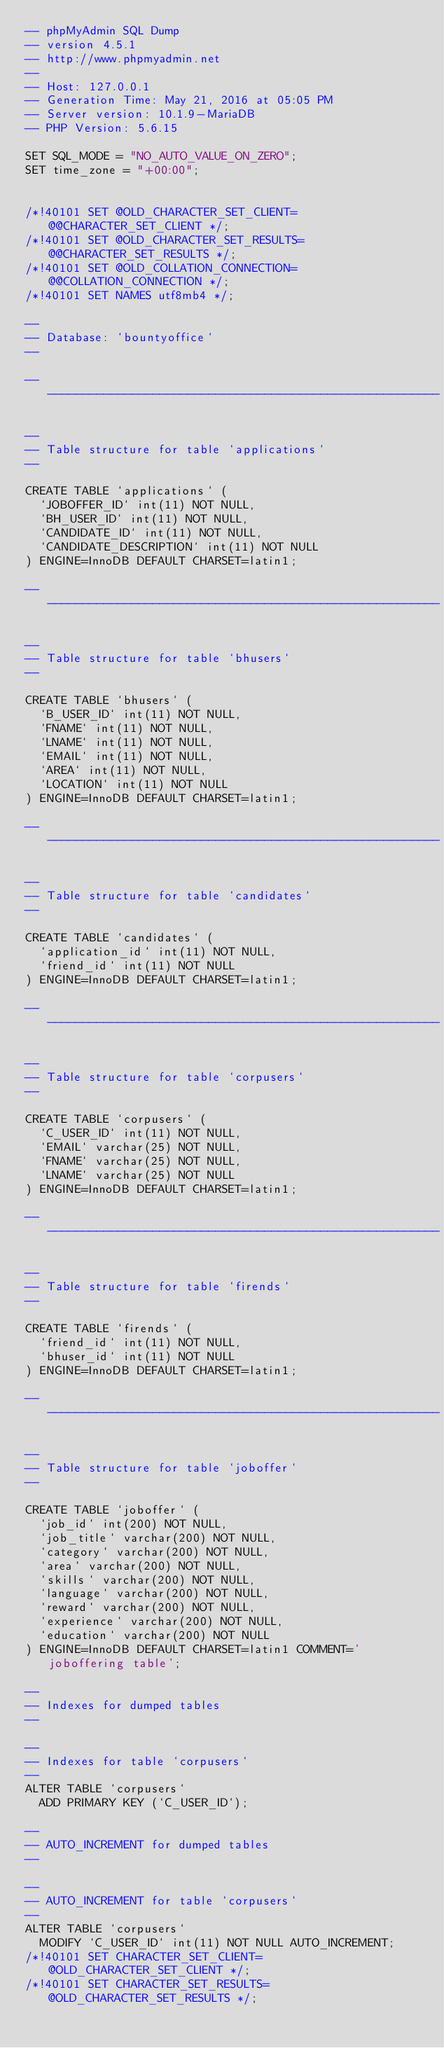Convert code to text. <code><loc_0><loc_0><loc_500><loc_500><_SQL_>-- phpMyAdmin SQL Dump
-- version 4.5.1
-- http://www.phpmyadmin.net
--
-- Host: 127.0.0.1
-- Generation Time: May 21, 2016 at 05:05 PM
-- Server version: 10.1.9-MariaDB
-- PHP Version: 5.6.15

SET SQL_MODE = "NO_AUTO_VALUE_ON_ZERO";
SET time_zone = "+00:00";


/*!40101 SET @OLD_CHARACTER_SET_CLIENT=@@CHARACTER_SET_CLIENT */;
/*!40101 SET @OLD_CHARACTER_SET_RESULTS=@@CHARACTER_SET_RESULTS */;
/*!40101 SET @OLD_COLLATION_CONNECTION=@@COLLATION_CONNECTION */;
/*!40101 SET NAMES utf8mb4 */;

--
-- Database: `bountyoffice`
--

-- --------------------------------------------------------

--
-- Table structure for table `applications`
--

CREATE TABLE `applications` (
  `JOBOFFER_ID` int(11) NOT NULL,
  `BH_USER_ID` int(11) NOT NULL,
  `CANDIDATE_ID` int(11) NOT NULL,
  `CANDIDATE_DESCRIPTION` int(11) NOT NULL
) ENGINE=InnoDB DEFAULT CHARSET=latin1;

-- --------------------------------------------------------

--
-- Table structure for table `bhusers`
--

CREATE TABLE `bhusers` (
  `B_USER_ID` int(11) NOT NULL,
  `FNAME` int(11) NOT NULL,
  `LNAME` int(11) NOT NULL,
  `EMAIL` int(11) NOT NULL,
  `AREA` int(11) NOT NULL,
  `LOCATION` int(11) NOT NULL
) ENGINE=InnoDB DEFAULT CHARSET=latin1;

-- --------------------------------------------------------

--
-- Table structure for table `candidates`
--

CREATE TABLE `candidates` (
  `application_id` int(11) NOT NULL,
  `friend_id` int(11) NOT NULL
) ENGINE=InnoDB DEFAULT CHARSET=latin1;

-- --------------------------------------------------------

--
-- Table structure for table `corpusers`
--

CREATE TABLE `corpusers` (
  `C_USER_ID` int(11) NOT NULL,
  `EMAIL` varchar(25) NOT NULL,
  `FNAME` varchar(25) NOT NULL,
  `LNAME` varchar(25) NOT NULL
) ENGINE=InnoDB DEFAULT CHARSET=latin1;

-- --------------------------------------------------------

--
-- Table structure for table `firends`
--

CREATE TABLE `firends` (
  `friend_id` int(11) NOT NULL,
  `bhuser_id` int(11) NOT NULL
) ENGINE=InnoDB DEFAULT CHARSET=latin1;

-- --------------------------------------------------------

--
-- Table structure for table `joboffer`
--

CREATE TABLE `joboffer` (
  `job_id` int(200) NOT NULL,
  `job_title` varchar(200) NOT NULL,
  `category` varchar(200) NOT NULL,
  `area` varchar(200) NOT NULL,
  `skills` varchar(200) NOT NULL,
  `language` varchar(200) NOT NULL,
  `reward` varchar(200) NOT NULL,
  `experience` varchar(200) NOT NULL,
  `education` varchar(200) NOT NULL
) ENGINE=InnoDB DEFAULT CHARSET=latin1 COMMENT='joboffering table';

--
-- Indexes for dumped tables
--

--
-- Indexes for table `corpusers`
--
ALTER TABLE `corpusers`
  ADD PRIMARY KEY (`C_USER_ID`);

--
-- AUTO_INCREMENT for dumped tables
--

--
-- AUTO_INCREMENT for table `corpusers`
--
ALTER TABLE `corpusers`
  MODIFY `C_USER_ID` int(11) NOT NULL AUTO_INCREMENT;
/*!40101 SET CHARACTER_SET_CLIENT=@OLD_CHARACTER_SET_CLIENT */;
/*!40101 SET CHARACTER_SET_RESULTS=@OLD_CHARACTER_SET_RESULTS */;</code> 